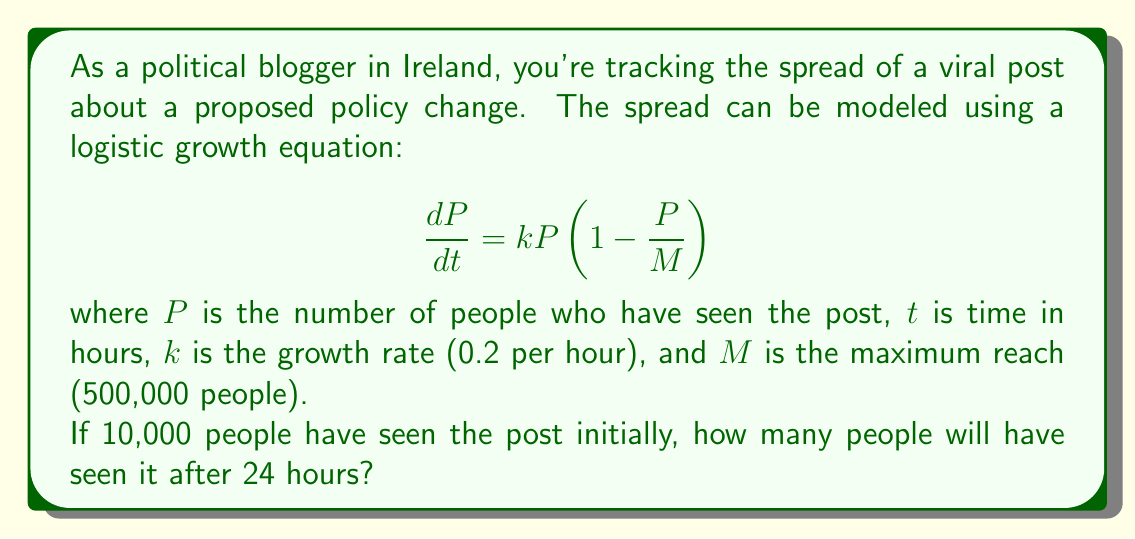Help me with this question. To solve this problem, we need to use the logistic growth model and integrate it. Here's the step-by-step solution:

1) The logistic differential equation is:

   $$\frac{dP}{dt} = kP(1-\frac{P}{M})$$

2) Separating variables:

   $$\frac{dP}{P(1-\frac{P}{M})} = kdt$$

3) Integrating both sides:

   $$\int \frac{dP}{P(1-\frac{P}{M})} = \int kdt$$

4) The left side integrates to:

   $$-\ln|1-\frac{P}{M}| - \ln|P| = kt + C$$

5) Solving for P:

   $$P = \frac{M}{1 + Ce^{-kt}}$$

6) Using the initial condition P(0) = 10,000:

   $$10000 = \frac{500000}{1 + C}$$
   $$C = 49$$

7) So our particular solution is:

   $$P = \frac{500000}{1 + 49e^{-0.2t}}$$

8) To find P(24), we substitute t = 24:

   $$P(24) = \frac{500000}{1 + 49e^{-0.2(24)}}$$

9) Calculating this value:

   $$P(24) = \frac{500000}{1 + 49e^{-4.8}} \approx 231,192$$
Answer: After 24 hours, approximately 231,192 people will have seen the viral post. 